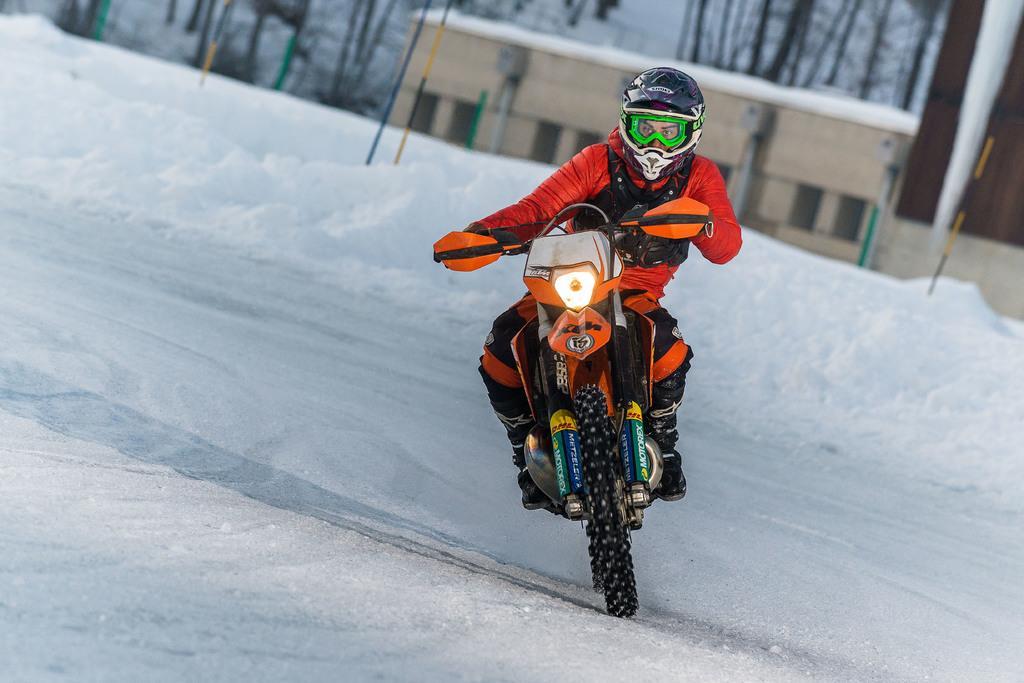Could you give a brief overview of what you see in this image? In the picture we can see a snow surface on it, we can see a man riding a bike and he is wearing a sportswear and a helmet and in the background also we can see snow and poles on it and behind it we can see a building and some trees behind it. 